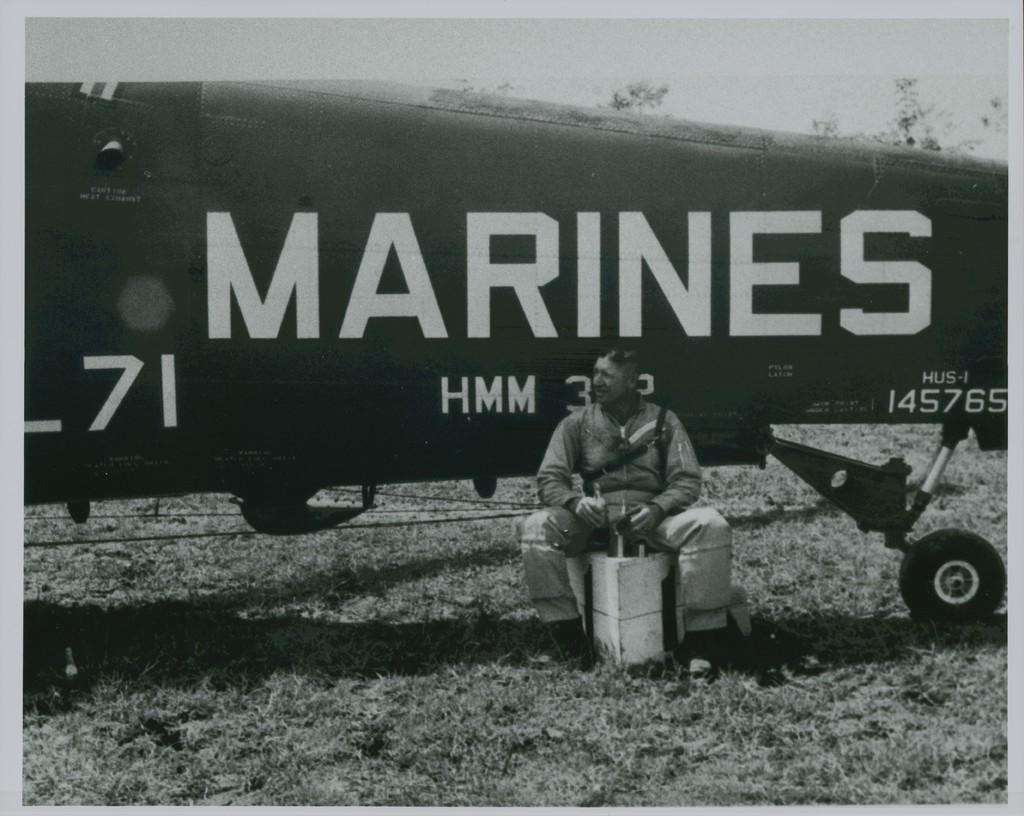<image>
Share a concise interpretation of the image provided. Man sitting in front of a black airplane for the Marines. 